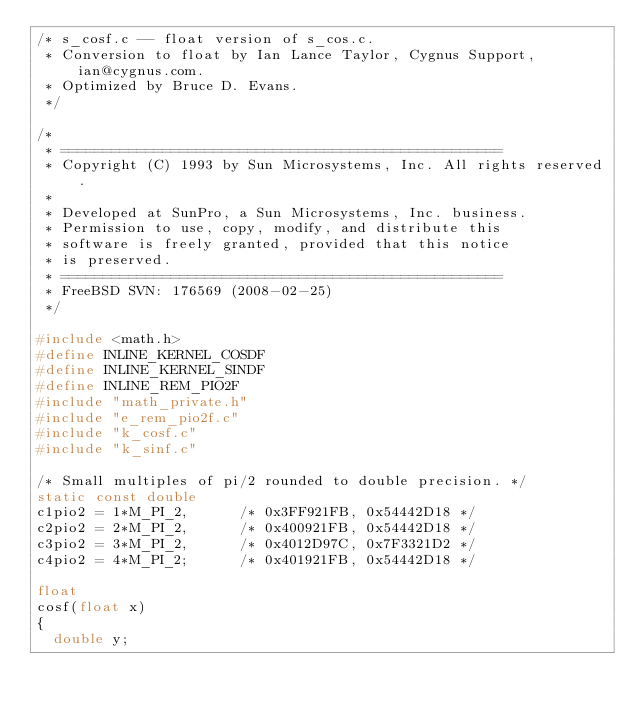<code> <loc_0><loc_0><loc_500><loc_500><_C_>/* s_cosf.c -- float version of s_cos.c.
 * Conversion to float by Ian Lance Taylor, Cygnus Support, ian@cygnus.com.
 * Optimized by Bruce D. Evans.
 */

/*
 * ====================================================
 * Copyright (C) 1993 by Sun Microsystems, Inc. All rights reserved.
 *
 * Developed at SunPro, a Sun Microsystems, Inc. business.
 * Permission to use, copy, modify, and distribute this
 * software is freely granted, provided that this notice
 * is preserved.
 * ====================================================
 * FreeBSD SVN: 176569 (2008-02-25)
 */

#include <math.h>
#define	INLINE_KERNEL_COSDF
#define	INLINE_KERNEL_SINDF
#define INLINE_REM_PIO2F
#include "math_private.h"
#include "e_rem_pio2f.c"
#include "k_cosf.c"
#include "k_sinf.c"

/* Small multiples of pi/2 rounded to double precision. */
static const double
c1pio2 = 1*M_PI_2,			/* 0x3FF921FB, 0x54442D18 */
c2pio2 = 2*M_PI_2,			/* 0x400921FB, 0x54442D18 */
c3pio2 = 3*M_PI_2,			/* 0x4012D97C, 0x7F3321D2 */
c4pio2 = 4*M_PI_2;			/* 0x401921FB, 0x54442D18 */

float
cosf(float x)
{
	double y;</code> 